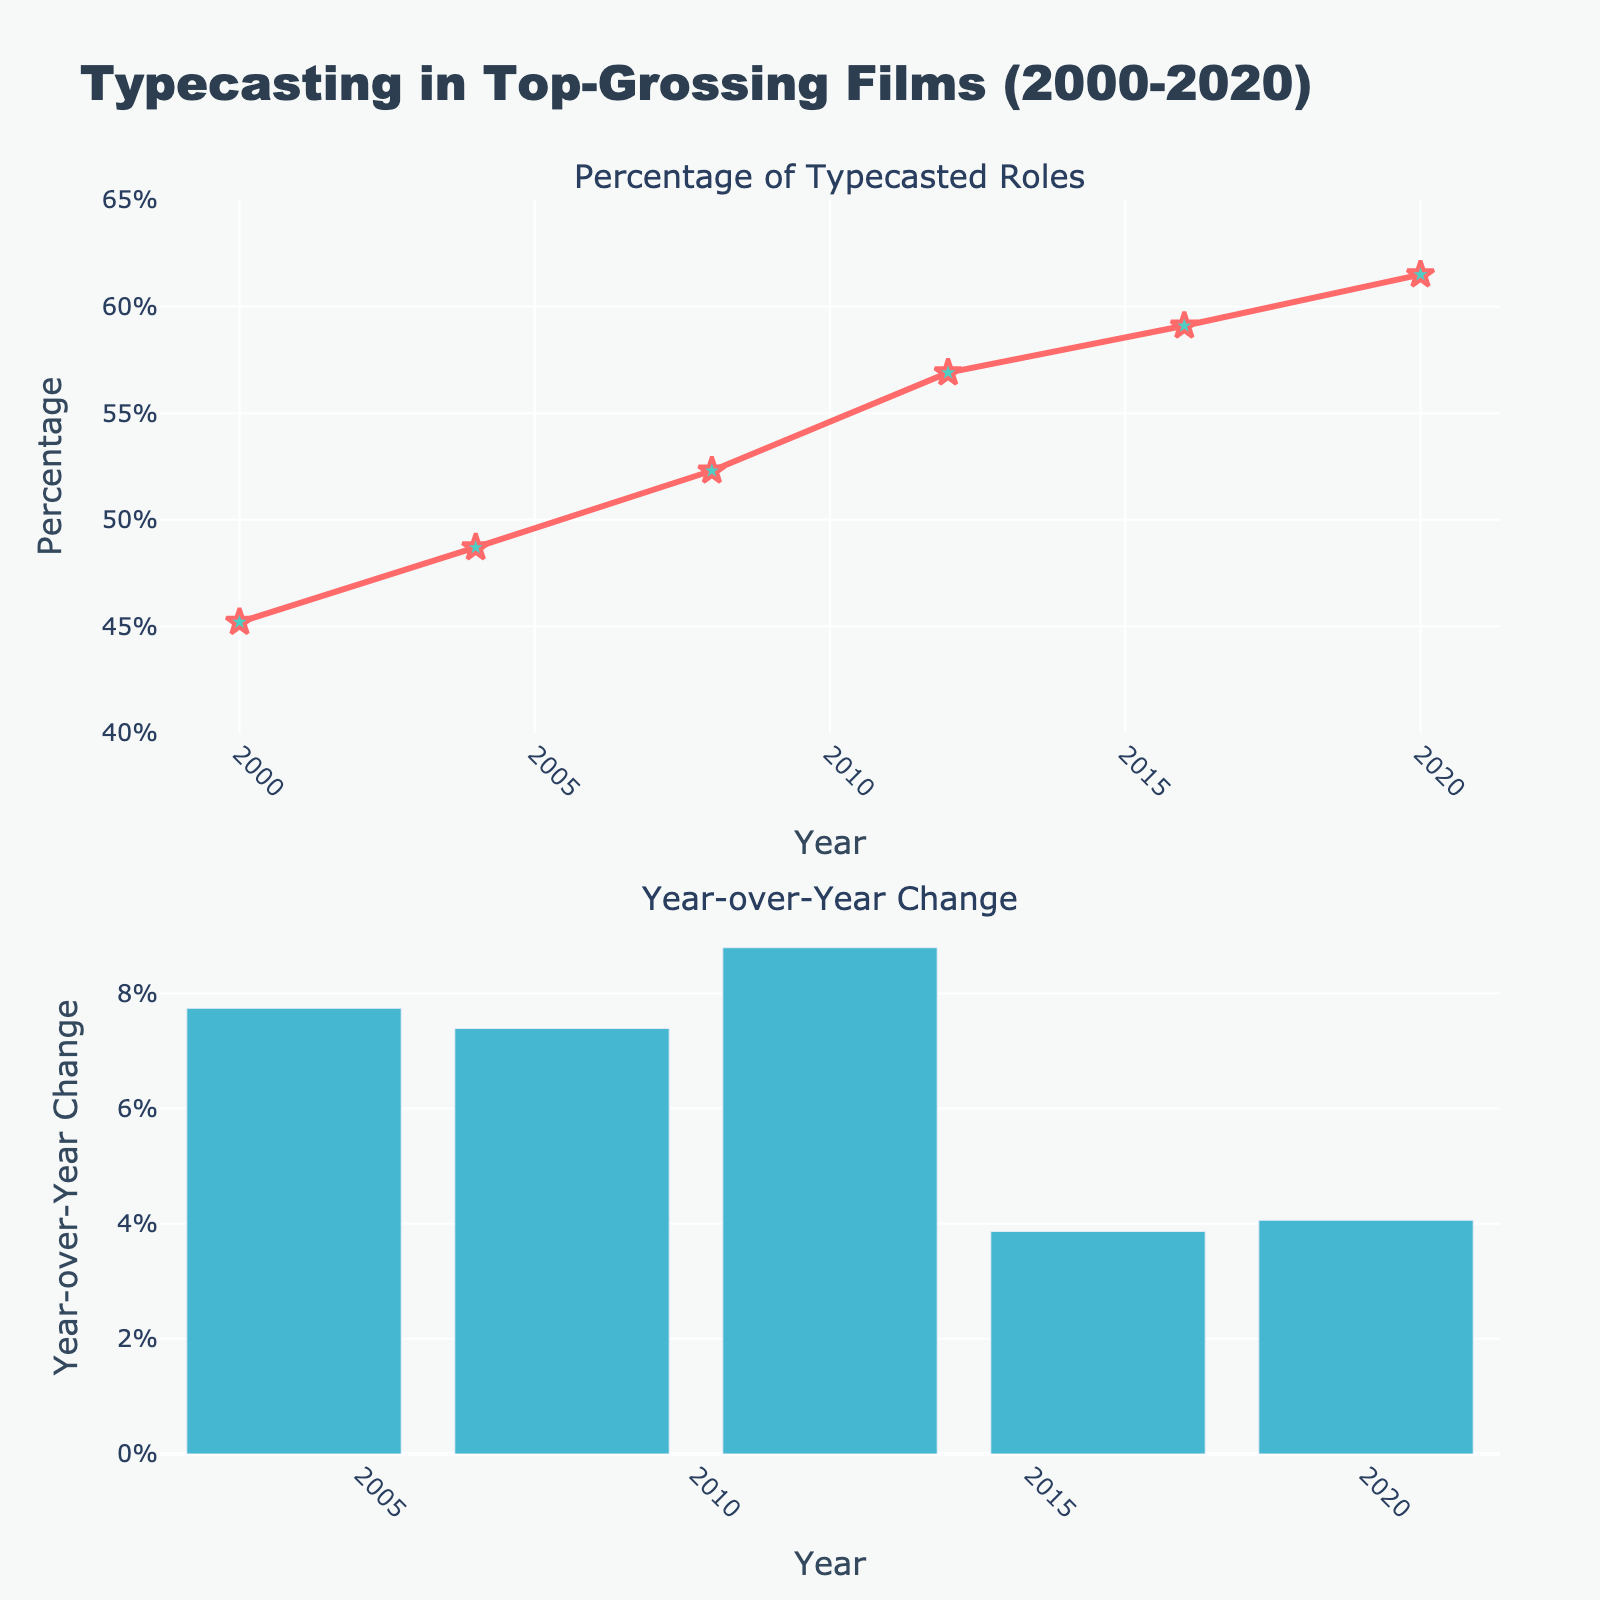What is the title of the figure? The title of the figure is typically placed at the top and is in bold. In this figure, the title is "Typecasting in Top-Grossing Films (2000-2020)."
Answer: Typecasting in Top-Grossing Films (2000-2020) What are the two subplots in the figure? The figure consists of two subplots, one above the other. The titles of these subplots can help identify their purpose. They are "Percentage of Typecasted Roles" and "Year-over-Year Change."
Answer: Percentage of Typecasted Roles and Year-over-Year Change What is the highest percentage of typecasted roles shown in the figure? By observing the y-axis and the data points in the first subplot, the highest percentage of typecasted roles is in the year 2020, which is 61.5%.
Answer: 61.5% Describe the general trend in the percentage of typecasted roles from 2000 to 2020. By examining the line plot in the first subplot, it can be seen that the percentage of typecasted roles has been steadily increasing from 45.2% in 2000 to 61.5% in 2020.
Answer: Increasing In which year did the percentage of typecasted roles first exceed 50%? By looking at the first subplot and identifying the year when the percentage crosses 50%, we see that it happens in 2008, when the percentage is 52.3%.
Answer: 2008 What is the year-over-year change in the percentage of typecasted roles from 2016 to 2020? Referring to the bar plot in the second subplot, the year-over-year changes for 2016 to 2020 can be summed up: (3.4 + 4.6). The calculated change is the sum of those changes.
Answer: 4.06% Which year has the highest year-over-year change in the percentage of typecasted roles? By examining the heights of the bars in the second subplot, the highest bar represents the year with the highest year-over-year change, which is 2012.
Answer: 2012 How does the percentage of typecasted roles in 2004 compare to 2008? By comparing the percentage values from the first subplot, the percentage in 2004 is 48.7% and in 2008 is 52.3%. Therefore, 2008 has a higher percentage than 2004.
Answer: 2008 is higher What is the overall percentage increase of typecasted roles from 2000 to 2020? To calculate the overall increase, subtract the percentage in 2000 from the percentage in 2020: 61.5% - 45.2% = 16.3%.
Answer: 16.3% 